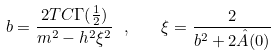Convert formula to latex. <formula><loc_0><loc_0><loc_500><loc_500>b = \frac { 2 T C \Gamma ( \frac { 1 } { 2 } ) } { m ^ { 2 } - h ^ { 2 } \xi ^ { 2 } } \ , \quad \xi = \frac { 2 } { b ^ { 2 } + 2 \hat { A } ( 0 ) }</formula> 